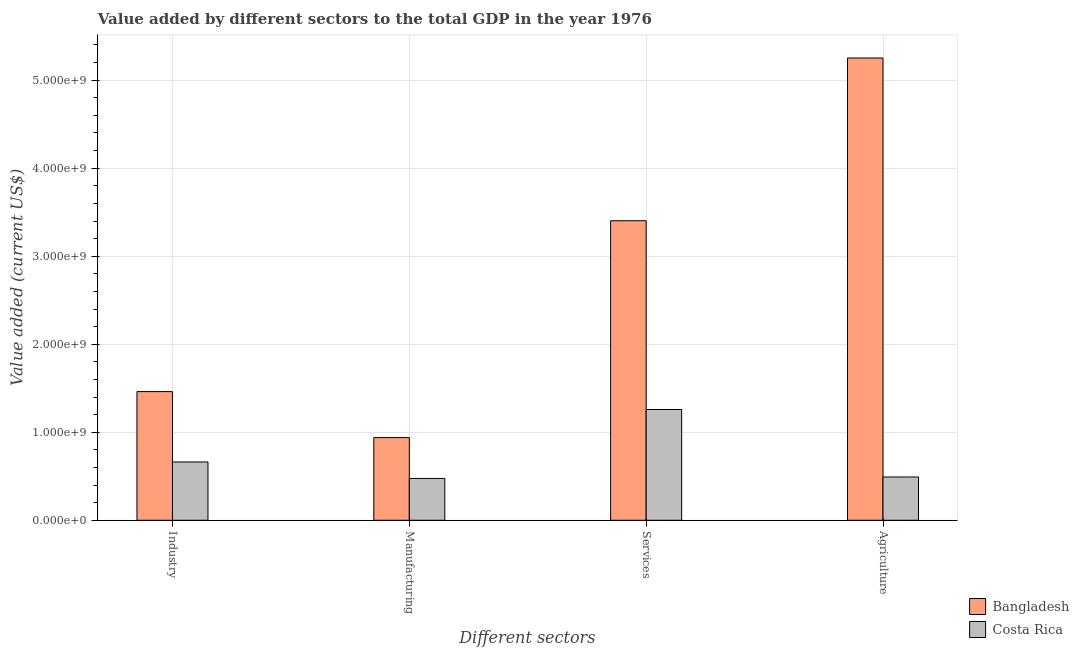How many different coloured bars are there?
Provide a succinct answer. 2. How many bars are there on the 2nd tick from the left?
Your answer should be compact. 2. How many bars are there on the 1st tick from the right?
Provide a succinct answer. 2. What is the label of the 2nd group of bars from the left?
Your answer should be compact. Manufacturing. What is the value added by agricultural sector in Bangladesh?
Your response must be concise. 5.25e+09. Across all countries, what is the maximum value added by agricultural sector?
Your answer should be very brief. 5.25e+09. Across all countries, what is the minimum value added by agricultural sector?
Provide a short and direct response. 4.92e+08. What is the total value added by industrial sector in the graph?
Your response must be concise. 2.12e+09. What is the difference between the value added by industrial sector in Costa Rica and that in Bangladesh?
Make the answer very short. -8.00e+08. What is the difference between the value added by industrial sector in Bangladesh and the value added by services sector in Costa Rica?
Provide a succinct answer. 2.03e+08. What is the average value added by services sector per country?
Your response must be concise. 2.33e+09. What is the difference between the value added by industrial sector and value added by manufacturing sector in Costa Rica?
Provide a short and direct response. 1.87e+08. What is the ratio of the value added by manufacturing sector in Costa Rica to that in Bangladesh?
Provide a succinct answer. 0.51. Is the value added by manufacturing sector in Bangladesh less than that in Costa Rica?
Give a very brief answer. No. Is the difference between the value added by manufacturing sector in Bangladesh and Costa Rica greater than the difference between the value added by services sector in Bangladesh and Costa Rica?
Provide a short and direct response. No. What is the difference between the highest and the second highest value added by agricultural sector?
Your response must be concise. 4.76e+09. What is the difference between the highest and the lowest value added by manufacturing sector?
Offer a very short reply. 4.64e+08. In how many countries, is the value added by industrial sector greater than the average value added by industrial sector taken over all countries?
Your answer should be very brief. 1. Is the sum of the value added by manufacturing sector in Bangladesh and Costa Rica greater than the maximum value added by services sector across all countries?
Provide a short and direct response. No. How many bars are there?
Give a very brief answer. 8. Are all the bars in the graph horizontal?
Your answer should be compact. No. What is the difference between two consecutive major ticks on the Y-axis?
Your answer should be compact. 1.00e+09. Does the graph contain any zero values?
Keep it short and to the point. No. How many legend labels are there?
Provide a succinct answer. 2. How are the legend labels stacked?
Make the answer very short. Vertical. What is the title of the graph?
Your answer should be compact. Value added by different sectors to the total GDP in the year 1976. What is the label or title of the X-axis?
Your response must be concise. Different sectors. What is the label or title of the Y-axis?
Offer a very short reply. Value added (current US$). What is the Value added (current US$) of Bangladesh in Industry?
Offer a terse response. 1.46e+09. What is the Value added (current US$) of Costa Rica in Industry?
Keep it short and to the point. 6.62e+08. What is the Value added (current US$) in Bangladesh in Manufacturing?
Provide a short and direct response. 9.39e+08. What is the Value added (current US$) in Costa Rica in Manufacturing?
Your answer should be compact. 4.75e+08. What is the Value added (current US$) in Bangladesh in Services?
Give a very brief answer. 3.40e+09. What is the Value added (current US$) of Costa Rica in Services?
Offer a terse response. 1.26e+09. What is the Value added (current US$) in Bangladesh in Agriculture?
Make the answer very short. 5.25e+09. What is the Value added (current US$) in Costa Rica in Agriculture?
Make the answer very short. 4.92e+08. Across all Different sectors, what is the maximum Value added (current US$) of Bangladesh?
Provide a short and direct response. 5.25e+09. Across all Different sectors, what is the maximum Value added (current US$) in Costa Rica?
Your answer should be compact. 1.26e+09. Across all Different sectors, what is the minimum Value added (current US$) in Bangladesh?
Your answer should be very brief. 9.39e+08. Across all Different sectors, what is the minimum Value added (current US$) of Costa Rica?
Provide a short and direct response. 4.75e+08. What is the total Value added (current US$) in Bangladesh in the graph?
Your response must be concise. 1.11e+1. What is the total Value added (current US$) in Costa Rica in the graph?
Ensure brevity in your answer.  2.89e+09. What is the difference between the Value added (current US$) in Bangladesh in Industry and that in Manufacturing?
Keep it short and to the point. 5.23e+08. What is the difference between the Value added (current US$) of Costa Rica in Industry and that in Manufacturing?
Make the answer very short. 1.87e+08. What is the difference between the Value added (current US$) of Bangladesh in Industry and that in Services?
Offer a terse response. -1.94e+09. What is the difference between the Value added (current US$) of Costa Rica in Industry and that in Services?
Your answer should be compact. -5.97e+08. What is the difference between the Value added (current US$) of Bangladesh in Industry and that in Agriculture?
Keep it short and to the point. -3.79e+09. What is the difference between the Value added (current US$) of Costa Rica in Industry and that in Agriculture?
Offer a very short reply. 1.71e+08. What is the difference between the Value added (current US$) in Bangladesh in Manufacturing and that in Services?
Make the answer very short. -2.46e+09. What is the difference between the Value added (current US$) of Costa Rica in Manufacturing and that in Services?
Ensure brevity in your answer.  -7.84e+08. What is the difference between the Value added (current US$) in Bangladesh in Manufacturing and that in Agriculture?
Your answer should be compact. -4.31e+09. What is the difference between the Value added (current US$) in Costa Rica in Manufacturing and that in Agriculture?
Provide a succinct answer. -1.64e+07. What is the difference between the Value added (current US$) of Bangladesh in Services and that in Agriculture?
Offer a very short reply. -1.85e+09. What is the difference between the Value added (current US$) of Costa Rica in Services and that in Agriculture?
Make the answer very short. 7.67e+08. What is the difference between the Value added (current US$) in Bangladesh in Industry and the Value added (current US$) in Costa Rica in Manufacturing?
Your answer should be compact. 9.87e+08. What is the difference between the Value added (current US$) in Bangladesh in Industry and the Value added (current US$) in Costa Rica in Services?
Provide a short and direct response. 2.03e+08. What is the difference between the Value added (current US$) of Bangladesh in Industry and the Value added (current US$) of Costa Rica in Agriculture?
Ensure brevity in your answer.  9.70e+08. What is the difference between the Value added (current US$) of Bangladesh in Manufacturing and the Value added (current US$) of Costa Rica in Services?
Provide a short and direct response. -3.19e+08. What is the difference between the Value added (current US$) in Bangladesh in Manufacturing and the Value added (current US$) in Costa Rica in Agriculture?
Offer a terse response. 4.48e+08. What is the difference between the Value added (current US$) of Bangladesh in Services and the Value added (current US$) of Costa Rica in Agriculture?
Ensure brevity in your answer.  2.91e+09. What is the average Value added (current US$) in Bangladesh per Different sectors?
Your answer should be very brief. 2.76e+09. What is the average Value added (current US$) in Costa Rica per Different sectors?
Provide a succinct answer. 7.22e+08. What is the difference between the Value added (current US$) in Bangladesh and Value added (current US$) in Costa Rica in Industry?
Provide a succinct answer. 8.00e+08. What is the difference between the Value added (current US$) of Bangladesh and Value added (current US$) of Costa Rica in Manufacturing?
Offer a very short reply. 4.64e+08. What is the difference between the Value added (current US$) in Bangladesh and Value added (current US$) in Costa Rica in Services?
Keep it short and to the point. 2.14e+09. What is the difference between the Value added (current US$) in Bangladesh and Value added (current US$) in Costa Rica in Agriculture?
Provide a succinct answer. 4.76e+09. What is the ratio of the Value added (current US$) of Bangladesh in Industry to that in Manufacturing?
Keep it short and to the point. 1.56. What is the ratio of the Value added (current US$) of Costa Rica in Industry to that in Manufacturing?
Your answer should be very brief. 1.39. What is the ratio of the Value added (current US$) in Bangladesh in Industry to that in Services?
Your answer should be very brief. 0.43. What is the ratio of the Value added (current US$) in Costa Rica in Industry to that in Services?
Make the answer very short. 0.53. What is the ratio of the Value added (current US$) of Bangladesh in Industry to that in Agriculture?
Provide a short and direct response. 0.28. What is the ratio of the Value added (current US$) in Costa Rica in Industry to that in Agriculture?
Your answer should be very brief. 1.35. What is the ratio of the Value added (current US$) in Bangladesh in Manufacturing to that in Services?
Your response must be concise. 0.28. What is the ratio of the Value added (current US$) of Costa Rica in Manufacturing to that in Services?
Keep it short and to the point. 0.38. What is the ratio of the Value added (current US$) in Bangladesh in Manufacturing to that in Agriculture?
Offer a terse response. 0.18. What is the ratio of the Value added (current US$) in Costa Rica in Manufacturing to that in Agriculture?
Give a very brief answer. 0.97. What is the ratio of the Value added (current US$) in Bangladesh in Services to that in Agriculture?
Give a very brief answer. 0.65. What is the ratio of the Value added (current US$) in Costa Rica in Services to that in Agriculture?
Give a very brief answer. 2.56. What is the difference between the highest and the second highest Value added (current US$) of Bangladesh?
Make the answer very short. 1.85e+09. What is the difference between the highest and the second highest Value added (current US$) of Costa Rica?
Your response must be concise. 5.97e+08. What is the difference between the highest and the lowest Value added (current US$) of Bangladesh?
Keep it short and to the point. 4.31e+09. What is the difference between the highest and the lowest Value added (current US$) of Costa Rica?
Make the answer very short. 7.84e+08. 